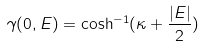Convert formula to latex. <formula><loc_0><loc_0><loc_500><loc_500>\gamma ( 0 , E ) = \cosh ^ { - 1 } ( \kappa + \frac { | E | } { 2 } )</formula> 